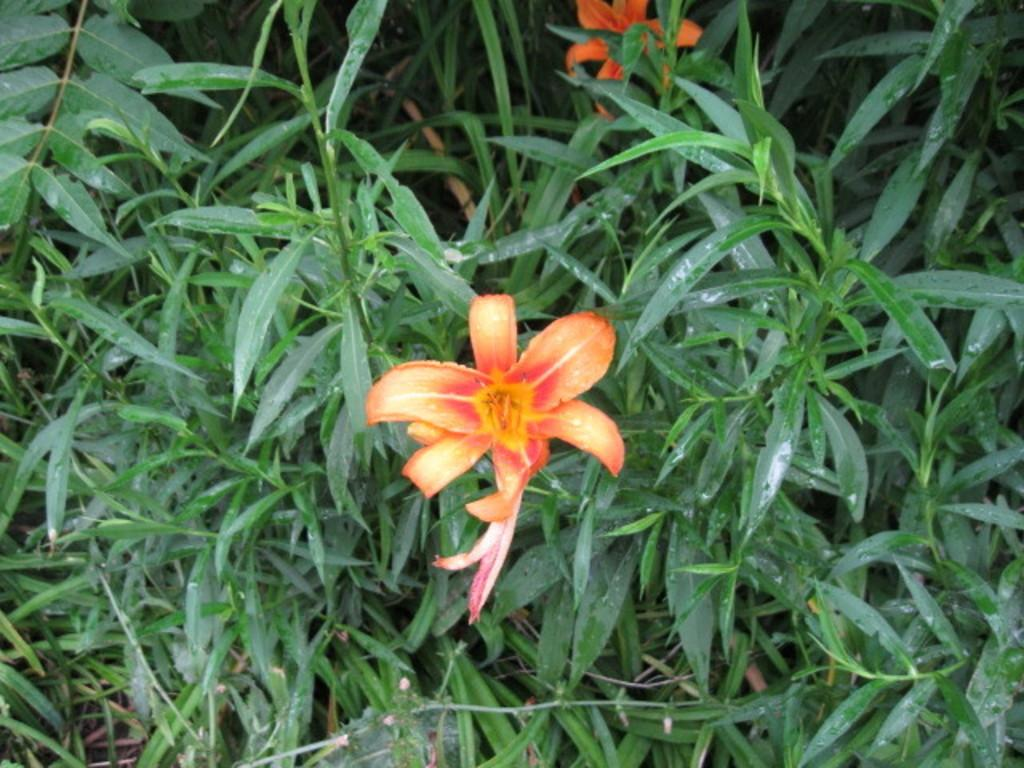What type of living organisms can be seen in the image? Plants can be seen in the image. Can you describe the flowers in the image? There are two flowers in the front of the image. What else can be seen in the front of the image besides the flowers? There are leaves in the front of the image. How does the scarecrow in the image breathe? There is no scarecrow present in the image, so it cannot be determined how it would breathe. 